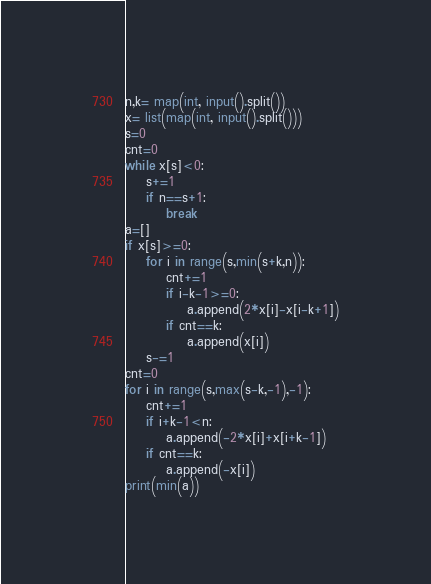Convert code to text. <code><loc_0><loc_0><loc_500><loc_500><_Python_>n,k= map(int, input().split())
x= list(map(int, input().split()))
s=0
cnt=0
while x[s]<0:
    s+=1
    if n==s+1:
        break
a=[]
if x[s]>=0:
    for i in range(s,min(s+k,n)):
        cnt+=1
        if i-k-1>=0:
            a.append(2*x[i]-x[i-k+1])
        if cnt==k:
            a.append(x[i])
    s-=1
cnt=0
for i in range(s,max(s-k,-1),-1):
    cnt+=1
    if i+k-1<n:
        a.append(-2*x[i]+x[i+k-1])
    if cnt==k:
        a.append(-x[i])
print(min(a))</code> 